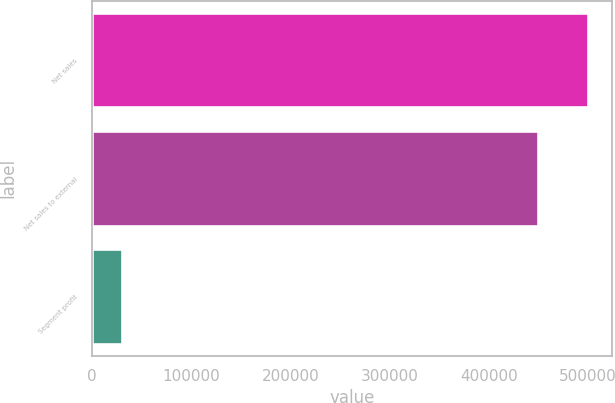Convert chart. <chart><loc_0><loc_0><loc_500><loc_500><bar_chart><fcel>Net sales<fcel>Net sales to external<fcel>Segment profit<nl><fcel>499583<fcel>449322<fcel>30274<nl></chart> 